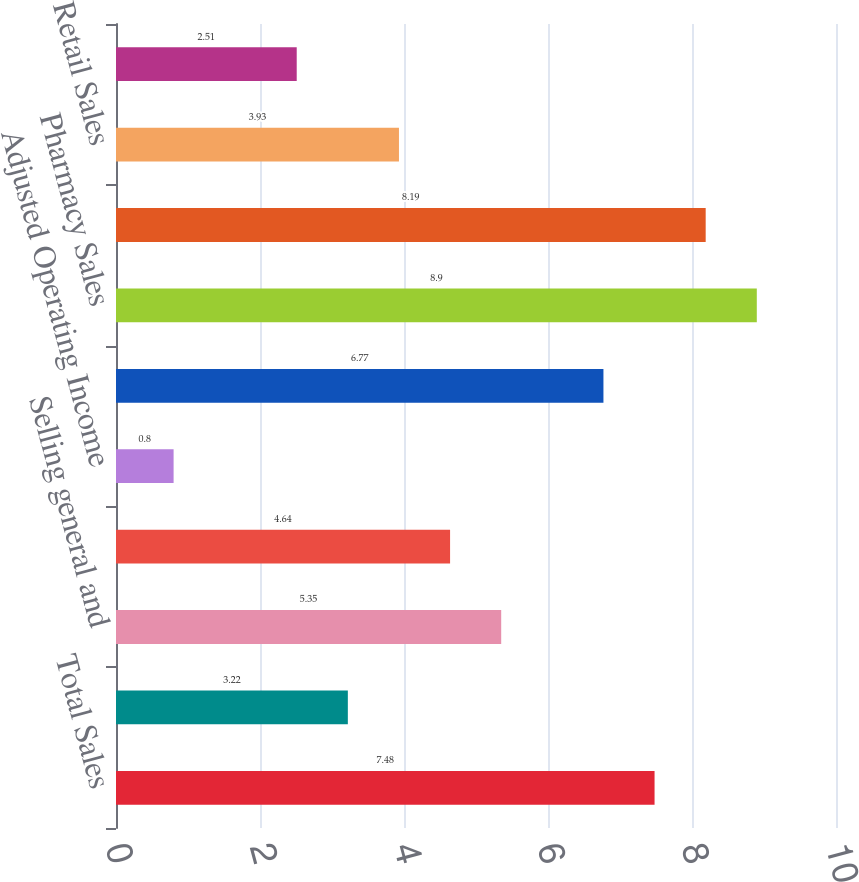Convert chart to OTSL. <chart><loc_0><loc_0><loc_500><loc_500><bar_chart><fcel>Total Sales<fcel>Gross Profit<fcel>Selling general and<fcel>Operating Income<fcel>Adjusted Operating Income<fcel>Comparable Drugstore Sales<fcel>Pharmacy Sales<fcel>Comparable Pharmacy Sales<fcel>Retail Sales<fcel>Comparable Retail Sales<nl><fcel>7.48<fcel>3.22<fcel>5.35<fcel>4.64<fcel>0.8<fcel>6.77<fcel>8.9<fcel>8.19<fcel>3.93<fcel>2.51<nl></chart> 